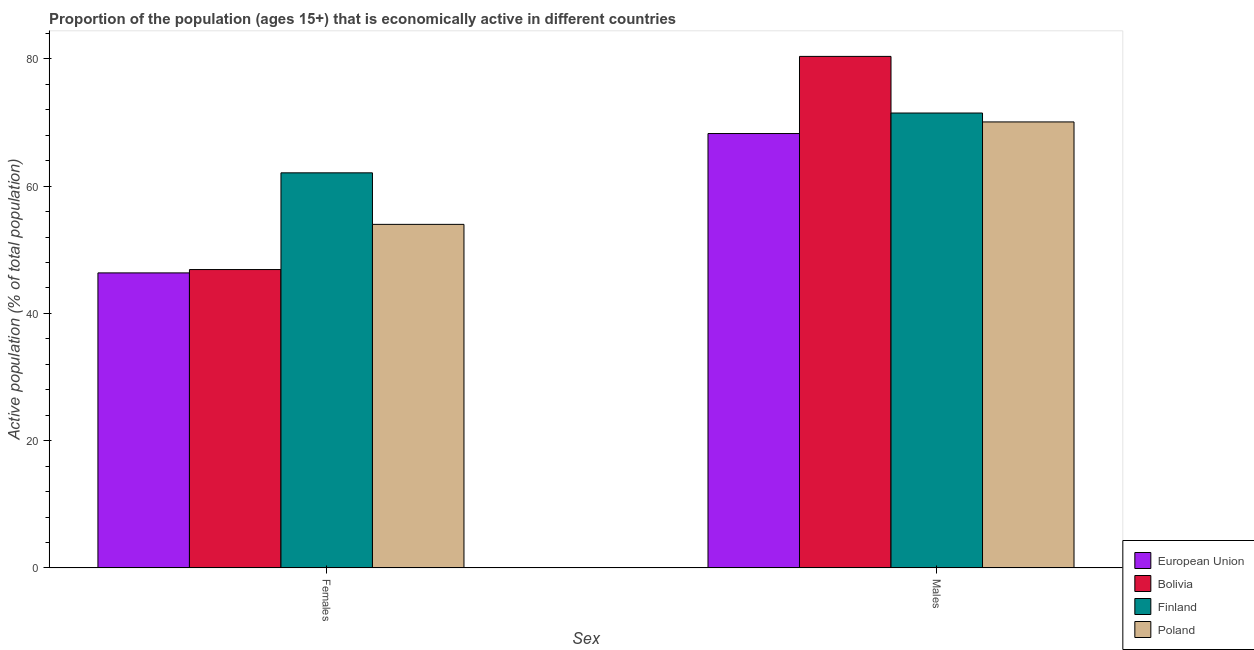How many different coloured bars are there?
Offer a terse response. 4. How many groups of bars are there?
Offer a terse response. 2. Are the number of bars per tick equal to the number of legend labels?
Your response must be concise. Yes. How many bars are there on the 1st tick from the left?
Provide a succinct answer. 4. What is the label of the 1st group of bars from the left?
Make the answer very short. Females. What is the percentage of economically active male population in European Union?
Provide a succinct answer. 68.28. Across all countries, what is the maximum percentage of economically active male population?
Offer a terse response. 80.4. Across all countries, what is the minimum percentage of economically active female population?
Give a very brief answer. 46.37. What is the total percentage of economically active male population in the graph?
Ensure brevity in your answer.  290.28. What is the difference between the percentage of economically active male population in European Union and that in Poland?
Provide a succinct answer. -1.82. What is the difference between the percentage of economically active female population in European Union and the percentage of economically active male population in Finland?
Ensure brevity in your answer.  -25.13. What is the average percentage of economically active male population per country?
Your response must be concise. 72.57. What is the difference between the percentage of economically active female population and percentage of economically active male population in Finland?
Provide a succinct answer. -9.4. What is the ratio of the percentage of economically active female population in Bolivia to that in Finland?
Your answer should be compact. 0.76. Is the percentage of economically active male population in Poland less than that in Bolivia?
Provide a succinct answer. Yes. In how many countries, is the percentage of economically active female population greater than the average percentage of economically active female population taken over all countries?
Offer a terse response. 2. What does the 4th bar from the left in Males represents?
Offer a very short reply. Poland. What does the 3rd bar from the right in Males represents?
Offer a very short reply. Bolivia. How many bars are there?
Ensure brevity in your answer.  8. Are all the bars in the graph horizontal?
Offer a very short reply. No. What is the difference between two consecutive major ticks on the Y-axis?
Provide a short and direct response. 20. Are the values on the major ticks of Y-axis written in scientific E-notation?
Ensure brevity in your answer.  No. How many legend labels are there?
Provide a short and direct response. 4. How are the legend labels stacked?
Your answer should be compact. Vertical. What is the title of the graph?
Give a very brief answer. Proportion of the population (ages 15+) that is economically active in different countries. What is the label or title of the X-axis?
Give a very brief answer. Sex. What is the label or title of the Y-axis?
Provide a short and direct response. Active population (% of total population). What is the Active population (% of total population) in European Union in Females?
Offer a terse response. 46.37. What is the Active population (% of total population) in Bolivia in Females?
Your answer should be compact. 46.9. What is the Active population (% of total population) in Finland in Females?
Give a very brief answer. 62.1. What is the Active population (% of total population) in Poland in Females?
Ensure brevity in your answer.  54. What is the Active population (% of total population) of European Union in Males?
Ensure brevity in your answer.  68.28. What is the Active population (% of total population) in Bolivia in Males?
Make the answer very short. 80.4. What is the Active population (% of total population) in Finland in Males?
Give a very brief answer. 71.5. What is the Active population (% of total population) in Poland in Males?
Keep it short and to the point. 70.1. Across all Sex, what is the maximum Active population (% of total population) in European Union?
Your answer should be very brief. 68.28. Across all Sex, what is the maximum Active population (% of total population) in Bolivia?
Ensure brevity in your answer.  80.4. Across all Sex, what is the maximum Active population (% of total population) of Finland?
Your response must be concise. 71.5. Across all Sex, what is the maximum Active population (% of total population) in Poland?
Your response must be concise. 70.1. Across all Sex, what is the minimum Active population (% of total population) in European Union?
Offer a very short reply. 46.37. Across all Sex, what is the minimum Active population (% of total population) in Bolivia?
Make the answer very short. 46.9. Across all Sex, what is the minimum Active population (% of total population) in Finland?
Your response must be concise. 62.1. What is the total Active population (% of total population) in European Union in the graph?
Your answer should be compact. 114.65. What is the total Active population (% of total population) in Bolivia in the graph?
Make the answer very short. 127.3. What is the total Active population (% of total population) in Finland in the graph?
Ensure brevity in your answer.  133.6. What is the total Active population (% of total population) of Poland in the graph?
Ensure brevity in your answer.  124.1. What is the difference between the Active population (% of total population) in European Union in Females and that in Males?
Your answer should be very brief. -21.9. What is the difference between the Active population (% of total population) in Bolivia in Females and that in Males?
Give a very brief answer. -33.5. What is the difference between the Active population (% of total population) in Finland in Females and that in Males?
Give a very brief answer. -9.4. What is the difference between the Active population (% of total population) of Poland in Females and that in Males?
Provide a succinct answer. -16.1. What is the difference between the Active population (% of total population) in European Union in Females and the Active population (% of total population) in Bolivia in Males?
Give a very brief answer. -34.03. What is the difference between the Active population (% of total population) of European Union in Females and the Active population (% of total population) of Finland in Males?
Provide a succinct answer. -25.13. What is the difference between the Active population (% of total population) in European Union in Females and the Active population (% of total population) in Poland in Males?
Offer a very short reply. -23.73. What is the difference between the Active population (% of total population) in Bolivia in Females and the Active population (% of total population) in Finland in Males?
Your answer should be very brief. -24.6. What is the difference between the Active population (% of total population) of Bolivia in Females and the Active population (% of total population) of Poland in Males?
Provide a short and direct response. -23.2. What is the difference between the Active population (% of total population) in Finland in Females and the Active population (% of total population) in Poland in Males?
Offer a terse response. -8. What is the average Active population (% of total population) of European Union per Sex?
Make the answer very short. 57.32. What is the average Active population (% of total population) of Bolivia per Sex?
Provide a short and direct response. 63.65. What is the average Active population (% of total population) in Finland per Sex?
Your response must be concise. 66.8. What is the average Active population (% of total population) in Poland per Sex?
Make the answer very short. 62.05. What is the difference between the Active population (% of total population) of European Union and Active population (% of total population) of Bolivia in Females?
Ensure brevity in your answer.  -0.53. What is the difference between the Active population (% of total population) in European Union and Active population (% of total population) in Finland in Females?
Your answer should be compact. -15.73. What is the difference between the Active population (% of total population) of European Union and Active population (% of total population) of Poland in Females?
Your answer should be very brief. -7.63. What is the difference between the Active population (% of total population) of Bolivia and Active population (% of total population) of Finland in Females?
Provide a short and direct response. -15.2. What is the difference between the Active population (% of total population) in Bolivia and Active population (% of total population) in Poland in Females?
Provide a succinct answer. -7.1. What is the difference between the Active population (% of total population) of European Union and Active population (% of total population) of Bolivia in Males?
Ensure brevity in your answer.  -12.12. What is the difference between the Active population (% of total population) in European Union and Active population (% of total population) in Finland in Males?
Your response must be concise. -3.22. What is the difference between the Active population (% of total population) of European Union and Active population (% of total population) of Poland in Males?
Offer a terse response. -1.82. What is the difference between the Active population (% of total population) in Bolivia and Active population (% of total population) in Poland in Males?
Make the answer very short. 10.3. What is the difference between the Active population (% of total population) of Finland and Active population (% of total population) of Poland in Males?
Make the answer very short. 1.4. What is the ratio of the Active population (% of total population) in European Union in Females to that in Males?
Offer a very short reply. 0.68. What is the ratio of the Active population (% of total population) of Bolivia in Females to that in Males?
Your answer should be very brief. 0.58. What is the ratio of the Active population (% of total population) of Finland in Females to that in Males?
Your answer should be very brief. 0.87. What is the ratio of the Active population (% of total population) in Poland in Females to that in Males?
Offer a very short reply. 0.77. What is the difference between the highest and the second highest Active population (% of total population) in European Union?
Offer a terse response. 21.9. What is the difference between the highest and the second highest Active population (% of total population) in Bolivia?
Your response must be concise. 33.5. What is the difference between the highest and the second highest Active population (% of total population) of Finland?
Make the answer very short. 9.4. What is the difference between the highest and the second highest Active population (% of total population) of Poland?
Your response must be concise. 16.1. What is the difference between the highest and the lowest Active population (% of total population) of European Union?
Your answer should be very brief. 21.9. What is the difference between the highest and the lowest Active population (% of total population) of Bolivia?
Offer a terse response. 33.5. What is the difference between the highest and the lowest Active population (% of total population) in Poland?
Your answer should be compact. 16.1. 